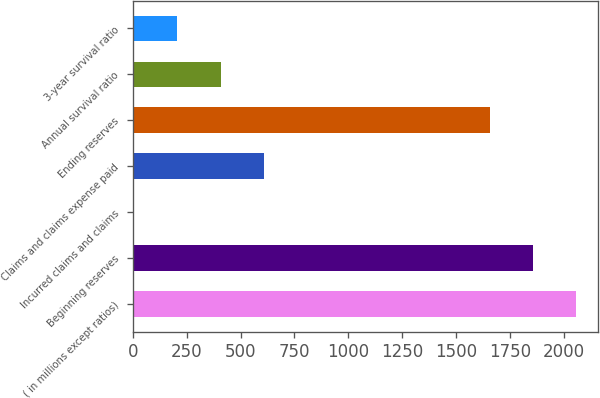<chart> <loc_0><loc_0><loc_500><loc_500><bar_chart><fcel>( in millions except ratios)<fcel>Beginning reserves<fcel>Incurred claims and claims<fcel>Claims and claims expense paid<fcel>Ending reserves<fcel>Annual survival ratio<fcel>3-year survival ratio<nl><fcel>2055.6<fcel>1855.3<fcel>7<fcel>607.9<fcel>1655<fcel>407.6<fcel>207.3<nl></chart> 